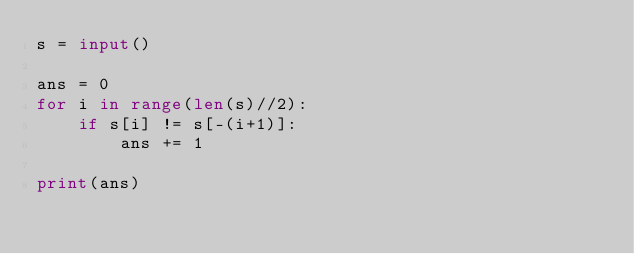<code> <loc_0><loc_0><loc_500><loc_500><_Python_>s = input()

ans = 0
for i in range(len(s)//2):
    if s[i] != s[-(i+1)]:
        ans += 1

print(ans)</code> 